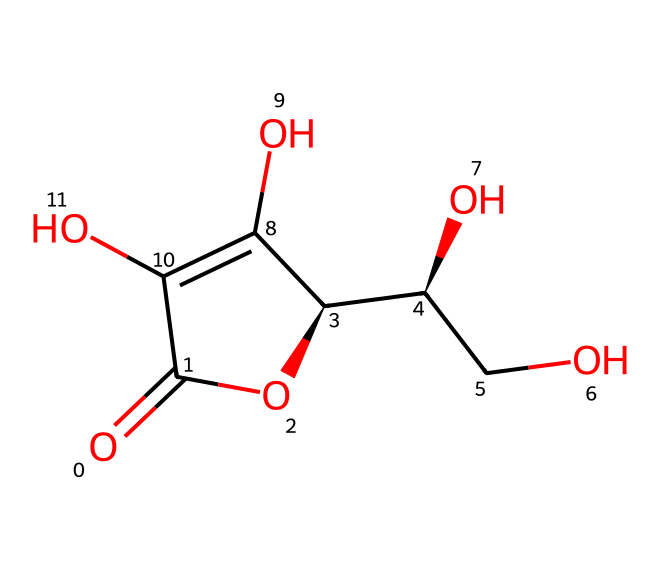What is the molecular formula of this vitamin? By analyzing the provided SMILES representation, we can count the atoms: there are 6 carbon (C) atoms, 8 hydrogen (H) atoms, and 6 oxygen (O) atoms. Thus, the molecular formula can be deduced as C6H8O6.
Answer: C6H8O6 How many hydroxyl (OH) groups are present in this structure? In the SMILES, the hydroxyl groups are represented by the letter "O" connected to a carbon atom with a hydrogen attached. By examining the structure, we can identify four hydroxyl groups.
Answer: four What type of bonds are present in this vitamin structure? The SMILES shows both single and double bonds; specifically, we see single bonds between most carbon and hydrogen atoms, and double bonds between some carbon and oxygen atoms.
Answer: single and double bonds What role does vitamin C play as an antioxidant? Vitamin C acts as an electron donor, which allows it to neutralize free radicals, thus preventing oxidative damage to cells. This property is integral to its function as a vitamin and antioxidant supplement.
Answer: antioxidant Why is the presence of multiple hydroxyl groups significant in vitamin C? Hydroxyl groups are polar, making vitamin C water-soluble and able to interact easily with various biological systems. This contributes to its efficacy in biological processes, particularly in antioxidant activity and cellular function.
Answer: water-soluble How many rings are present in the chemical structure of vitamin C? Upon reviewing the SMILES representation, we observe one ring structure that includes a total of six atoms (four carbons and two oxygens) forming a cyclic compound.
Answer: one ring What functional groups are identifiable in this vitamin's structure? The structure exhibits hydroxyl (OH) groups and a lactone group (cyclic ester), which are characteristic for the functionality of vitamin C as a water-soluble vitamin involved in various biochemical processes.
Answer: hydroxyl and lactone groups 